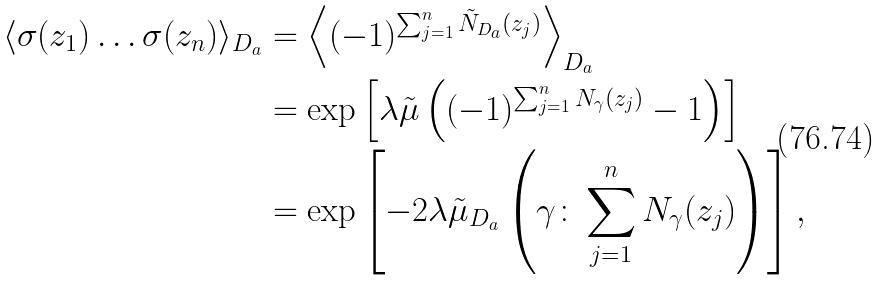Convert formula to latex. <formula><loc_0><loc_0><loc_500><loc_500>\langle \sigma ( z _ { 1 } ) \dots \sigma ( z _ { n } ) \rangle _ { D _ { a } } & = \left \langle ( - 1 ) ^ { \sum _ { j = 1 } ^ { n } \tilde { N } _ { D _ { a } } ( z _ { j } ) } \right \rangle _ { D _ { a } } \\ & = \exp \left [ \lambda \tilde { \mu } \left ( ( - 1 ) ^ { \sum _ { j = 1 } ^ { n } N _ { \gamma } ( z _ { j } ) } - 1 \right ) \right ] \\ & = \exp \left [ - 2 \lambda \tilde { \mu } _ { D _ { a } } \left ( \gamma \colon \sum _ { j = 1 } ^ { n } N _ { \gamma } ( z _ { j } ) \right ) \right ] ,</formula> 